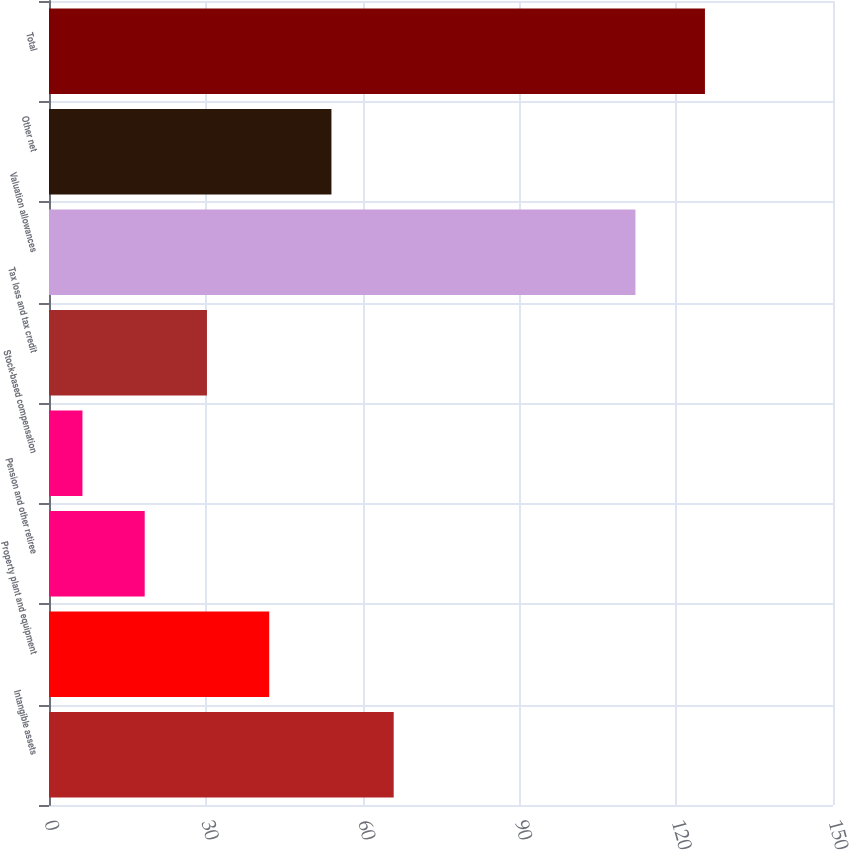Convert chart to OTSL. <chart><loc_0><loc_0><loc_500><loc_500><bar_chart><fcel>Intangible assets<fcel>Property plant and equipment<fcel>Pension and other retiree<fcel>Stock-based compensation<fcel>Tax loss and tax credit<fcel>Valuation allowances<fcel>Other net<fcel>Total<nl><fcel>65.95<fcel>42.13<fcel>18.31<fcel>6.4<fcel>30.22<fcel>112.2<fcel>54.04<fcel>125.5<nl></chart> 